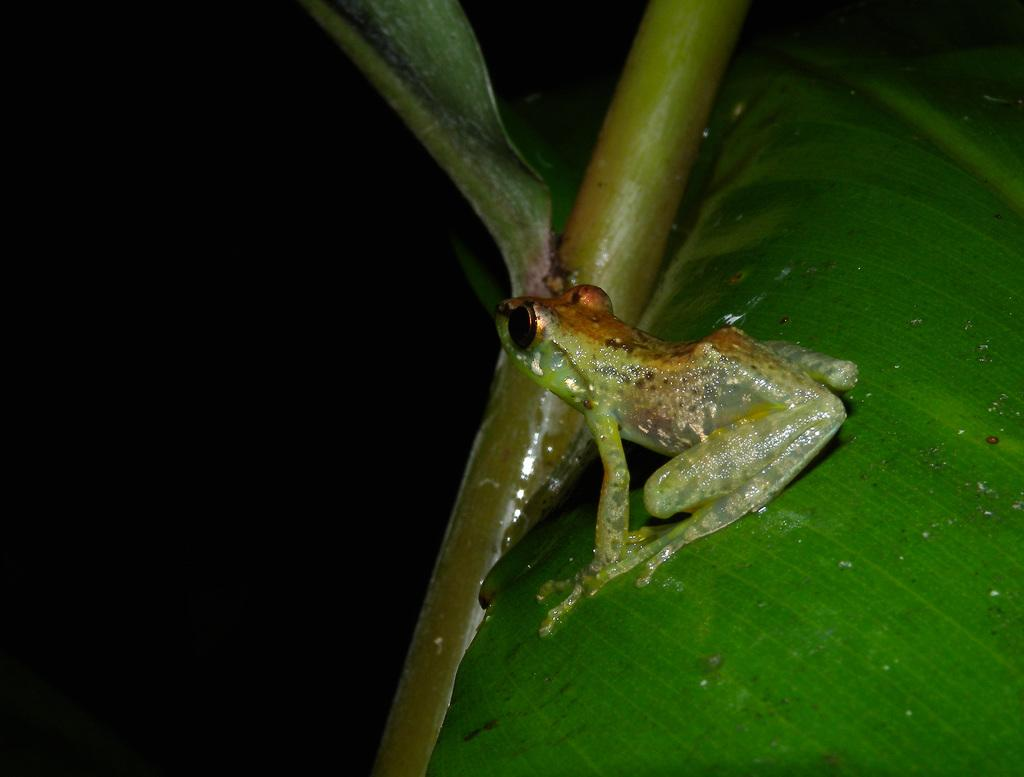What animal is present in the image? There is a frog in the image. Where is the frog located? The frog is sitting on a leaf. What type of underwear is the frog wearing in the image? There is no underwear present in the image, as frogs do not wear clothing. 